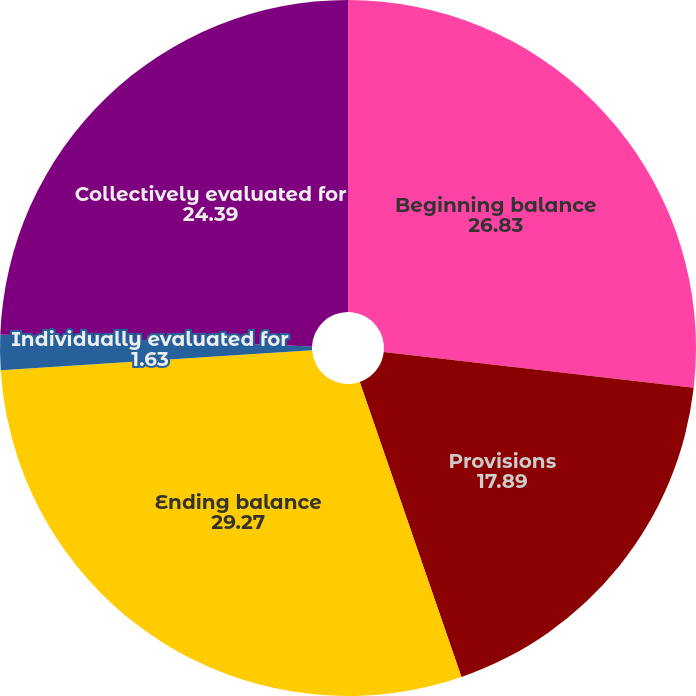<chart> <loc_0><loc_0><loc_500><loc_500><pie_chart><fcel>Beginning balance<fcel>Provisions<fcel>Ending balance<fcel>Individually evaluated for<fcel>Collectively evaluated for<nl><fcel>26.83%<fcel>17.89%<fcel>29.27%<fcel>1.63%<fcel>24.39%<nl></chart> 